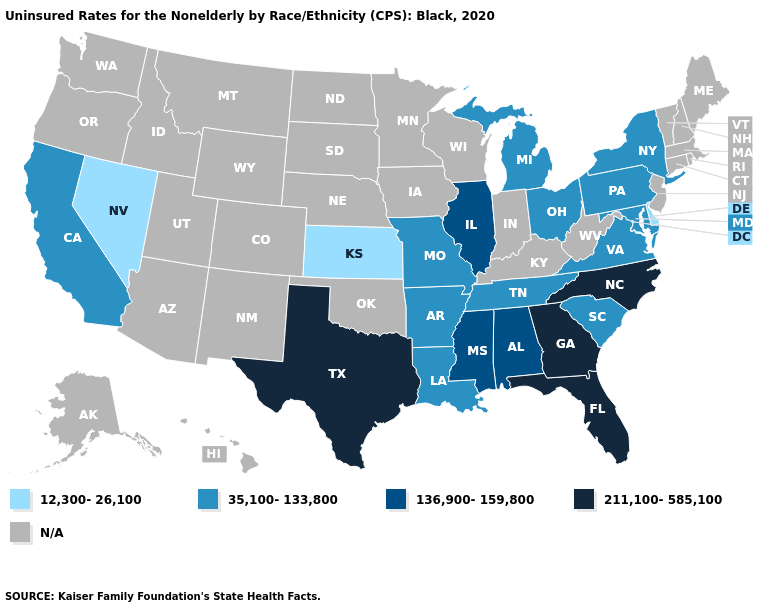Name the states that have a value in the range 211,100-585,100?
Keep it brief. Florida, Georgia, North Carolina, Texas. Name the states that have a value in the range 35,100-133,800?
Short answer required. Arkansas, California, Louisiana, Maryland, Michigan, Missouri, New York, Ohio, Pennsylvania, South Carolina, Tennessee, Virginia. Does Kansas have the lowest value in the USA?
Concise answer only. Yes. Which states have the lowest value in the USA?
Answer briefly. Delaware, Kansas, Nevada. How many symbols are there in the legend?
Keep it brief. 5. Does Delaware have the lowest value in the USA?
Give a very brief answer. Yes. What is the value of Tennessee?
Answer briefly. 35,100-133,800. What is the value of Rhode Island?
Concise answer only. N/A. Name the states that have a value in the range 12,300-26,100?
Quick response, please. Delaware, Kansas, Nevada. Among the states that border Nebraska , does Missouri have the lowest value?
Answer briefly. No. What is the lowest value in the USA?
Answer briefly. 12,300-26,100. What is the lowest value in the USA?
Concise answer only. 12,300-26,100. Name the states that have a value in the range N/A?
Be succinct. Alaska, Arizona, Colorado, Connecticut, Hawaii, Idaho, Indiana, Iowa, Kentucky, Maine, Massachusetts, Minnesota, Montana, Nebraska, New Hampshire, New Jersey, New Mexico, North Dakota, Oklahoma, Oregon, Rhode Island, South Dakota, Utah, Vermont, Washington, West Virginia, Wisconsin, Wyoming. What is the lowest value in the USA?
Be succinct. 12,300-26,100. Among the states that border Utah , which have the highest value?
Short answer required. Nevada. 